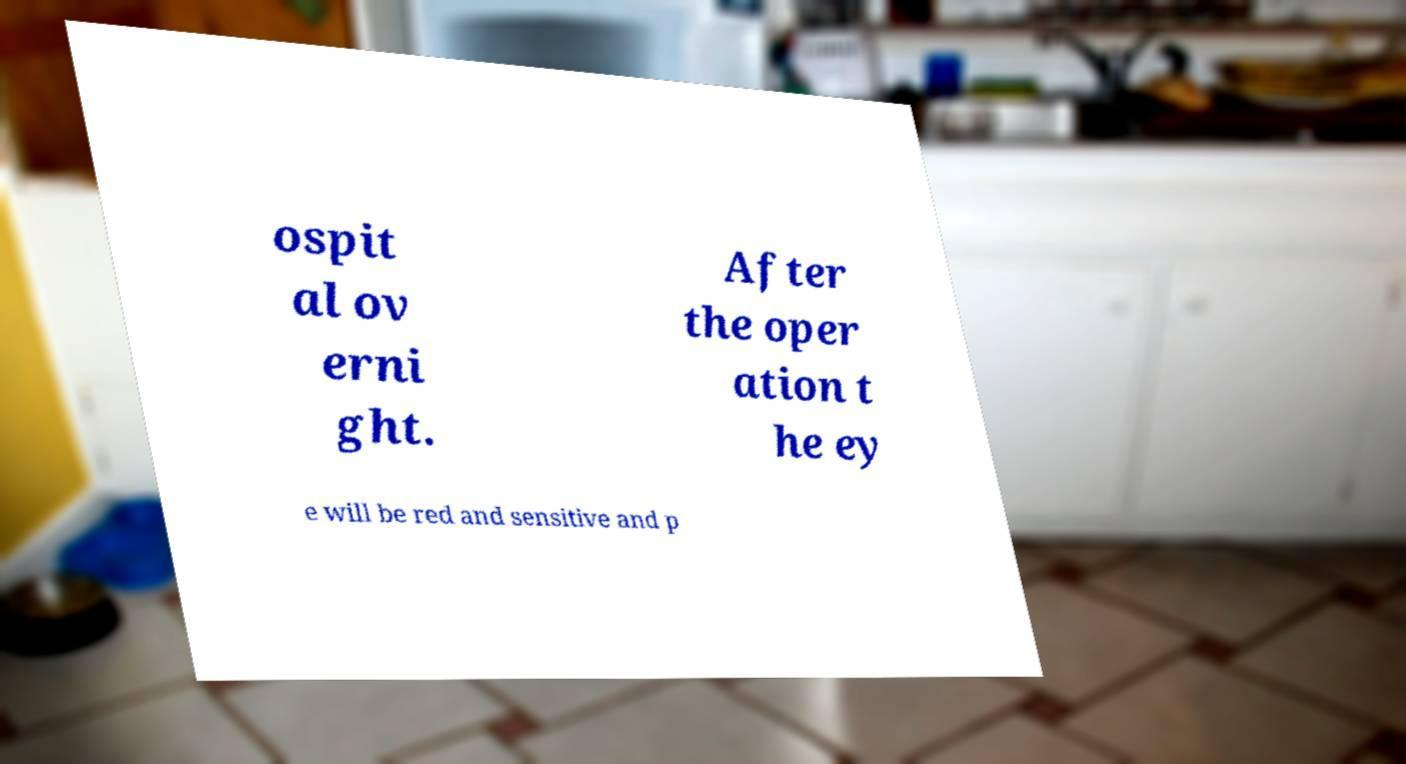Could you assist in decoding the text presented in this image and type it out clearly? ospit al ov erni ght. After the oper ation t he ey e will be red and sensitive and p 